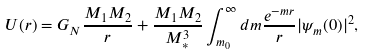Convert formula to latex. <formula><loc_0><loc_0><loc_500><loc_500>U ( r ) = G _ { N } \frac { M _ { 1 } M _ { 2 } } { r } + \frac { M _ { 1 } M _ { 2 } } { M _ { * } ^ { 3 } } \int _ { m _ { 0 } } ^ { \infty } { d m \frac { e ^ { - m r } } { r } | \psi _ { m } ( 0 ) | ^ { 2 } } ,</formula> 